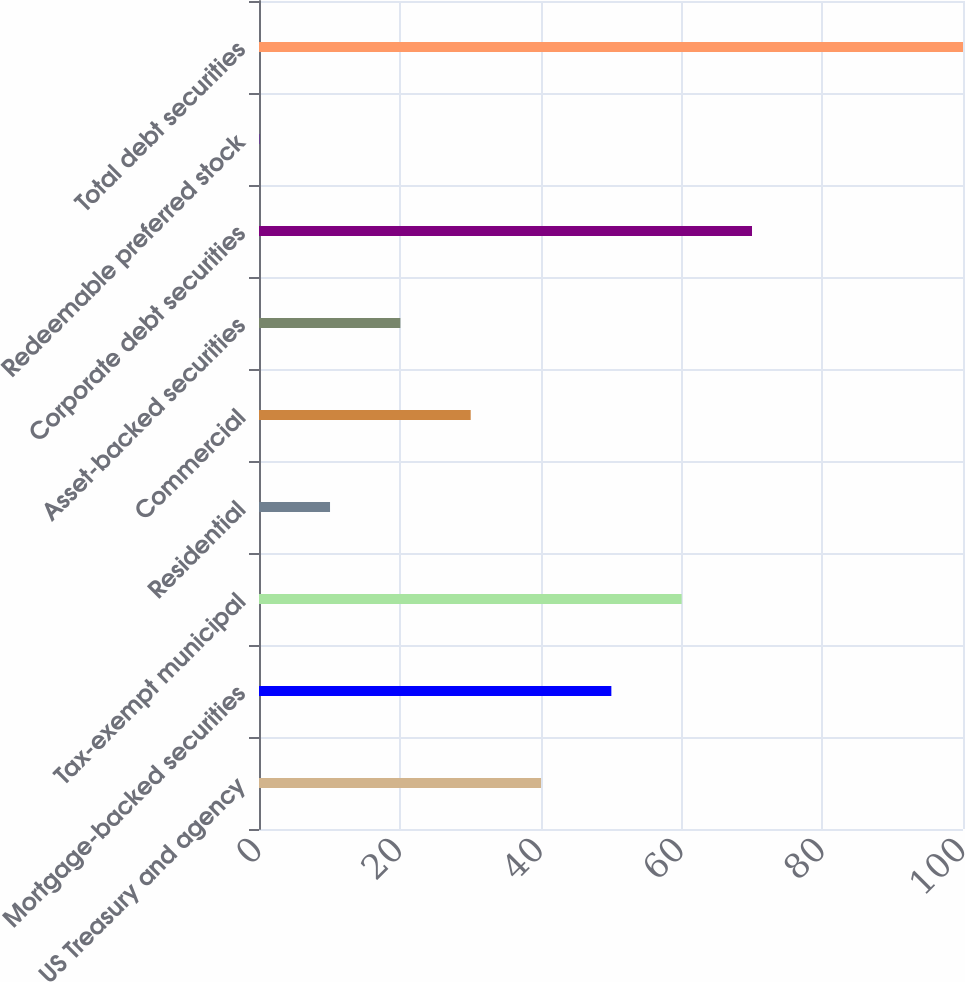Convert chart to OTSL. <chart><loc_0><loc_0><loc_500><loc_500><bar_chart><fcel>US Treasury and agency<fcel>Mortgage-backed securities<fcel>Tax-exempt municipal<fcel>Residential<fcel>Commercial<fcel>Asset-backed securities<fcel>Corporate debt securities<fcel>Redeemable preferred stock<fcel>Total debt securities<nl><fcel>40.06<fcel>50.05<fcel>60.04<fcel>10.09<fcel>30.07<fcel>20.08<fcel>70.03<fcel>0.1<fcel>100<nl></chart> 